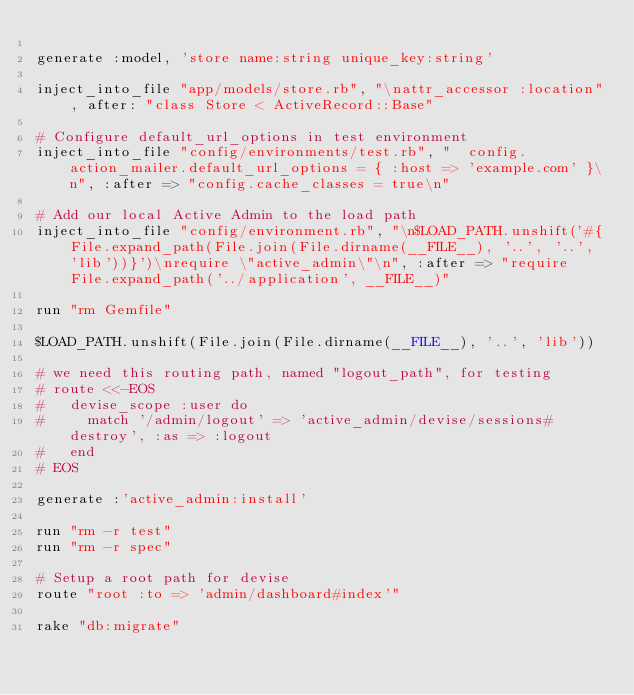Convert code to text. <code><loc_0><loc_0><loc_500><loc_500><_Ruby_>
generate :model, 'store name:string unique_key:string'

inject_into_file "app/models/store.rb", "\nattr_accessor :location", after: "class Store < ActiveRecord::Base"

# Configure default_url_options in test environment
inject_into_file "config/environments/test.rb", "  config.action_mailer.default_url_options = { :host => 'example.com' }\n", :after => "config.cache_classes = true\n"

# Add our local Active Admin to the load path
inject_into_file "config/environment.rb", "\n$LOAD_PATH.unshift('#{File.expand_path(File.join(File.dirname(__FILE__), '..', '..', 'lib'))}')\nrequire \"active_admin\"\n", :after => "require File.expand_path('../application', __FILE__)"

run "rm Gemfile"

$LOAD_PATH.unshift(File.join(File.dirname(__FILE__), '..', 'lib'))

# we need this routing path, named "logout_path", for testing
# route <<-EOS
#   devise_scope :user do
#     match '/admin/logout' => 'active_admin/devise/sessions#destroy', :as => :logout
#   end
# EOS

generate :'active_admin:install'

run "rm -r test"
run "rm -r spec"

# Setup a root path for devise
route "root :to => 'admin/dashboard#index'"

rake "db:migrate"

</code> 